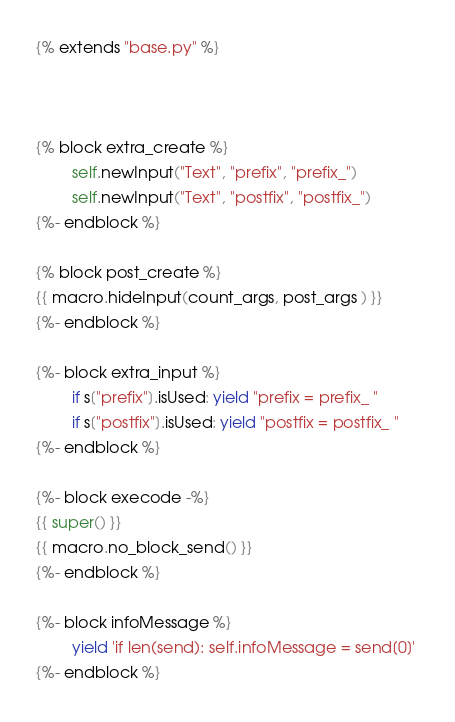Convert code to text. <code><loc_0><loc_0><loc_500><loc_500><_Python_>{% extends "base.py" %}



{% block extra_create %}
        self.newInput("Text", "prefix", "prefix_")
        self.newInput("Text", "postfix", "postfix_")
{%- endblock %}

{% block post_create %}
{{ macro.hideInput(count_args, post_args ) }}       
{%- endblock %}

{%- block extra_input %}
        if s["prefix"].isUsed: yield "prefix = prefix_ "
        if s["postfix"].isUsed: yield "postfix = postfix_ "
{%- endblock %}

{%- block execode -%}
{{ super() }}  
{{ macro.no_block_send() }}         
{%- endblock %}

{%- block infoMessage %}
        yield 'if len(send): self.infoMessage = send[0]' 
{%- endblock %}</code> 